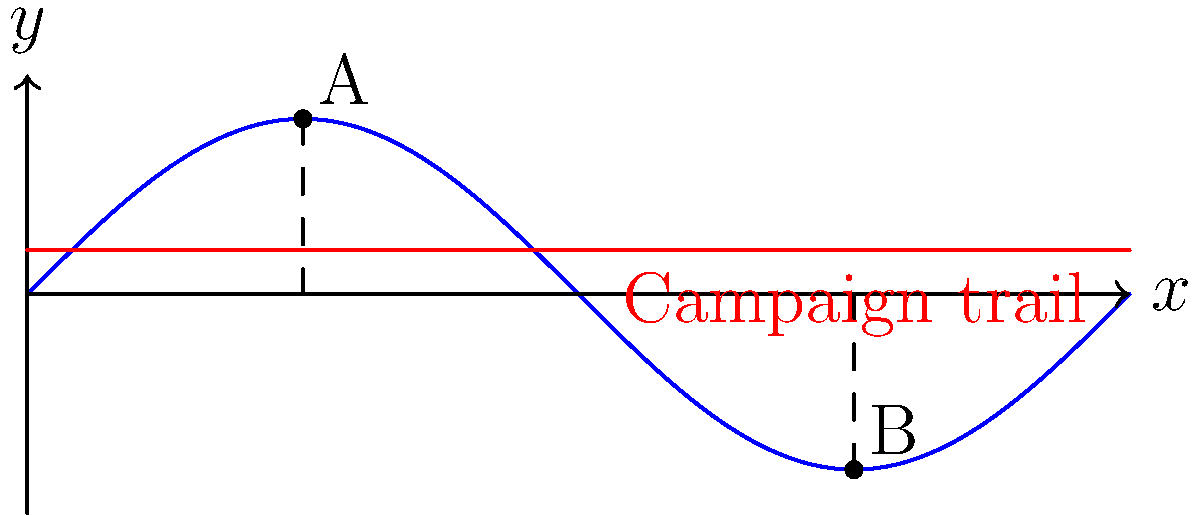A political campaign bus is traveling on a curved road modeled by the function $y = 2\sin(\frac{x}{2})$, where $x$ is measured in kilometers and $y$ in meters. The bus starts at point A $(π, 2)$ and ends at point B $(3π, -2)$. If the bus maintains a constant height of 0.5 meters above the road surface, calculate the total vertical distance traveled by the bus between points A and B. To solve this problem, we'll follow these steps:

1) The bus maintains a constant height of 0.5 meters above the road surface. This means we need to calculate the change in the road's height between points A and B.

2) At point A: $x = π$
   $y_A = 2\sin(\frac{π}{2}) = 2$

3) At point B: $x = 3π$
   $y_B = 2\sin(\frac{3π}{2}) = -2$

4) The total change in height of the road is:
   $\Delta y = y_B - y_A = -2 - 2 = -4$ meters

5) The negative sign indicates that the road has decreased in height by 4 meters from A to B.

6) Since the bus maintains a constant height above the road, it will travel the same vertical distance as the change in the road's height.

7) Therefore, the total vertical distance traveled by the bus is the absolute value of this change: $|Δy| = |-4| = 4$ meters.
Answer: 4 meters 